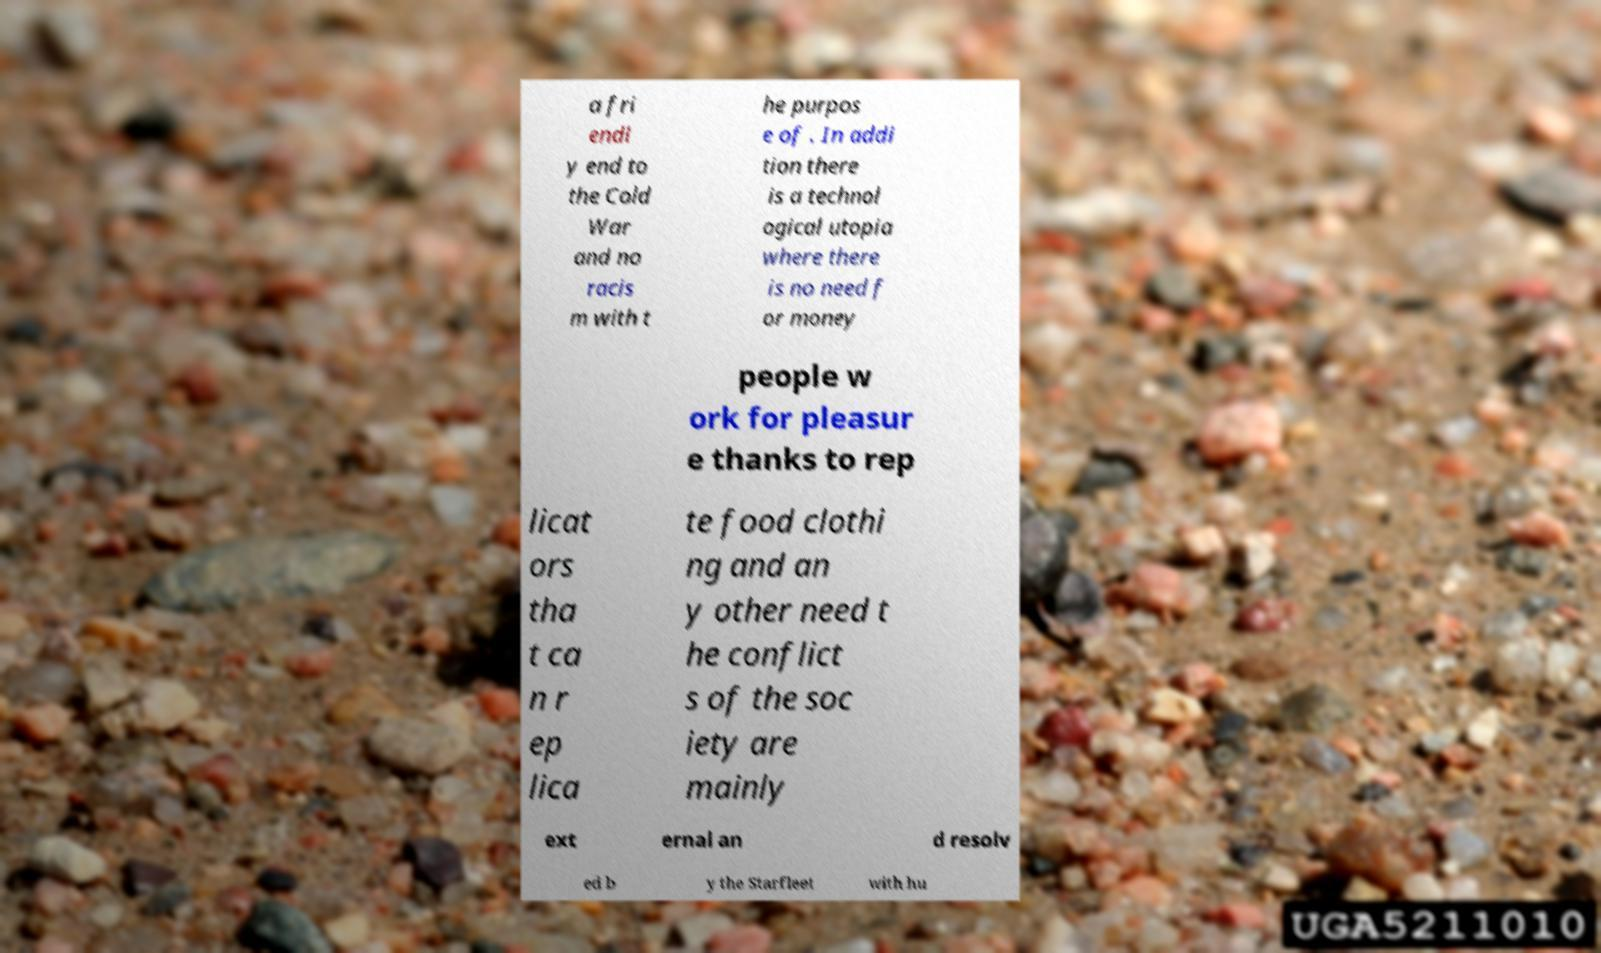I need the written content from this picture converted into text. Can you do that? a fri endl y end to the Cold War and no racis m with t he purpos e of . In addi tion there is a technol ogical utopia where there is no need f or money people w ork for pleasur e thanks to rep licat ors tha t ca n r ep lica te food clothi ng and an y other need t he conflict s of the soc iety are mainly ext ernal an d resolv ed b y the Starfleet with hu 